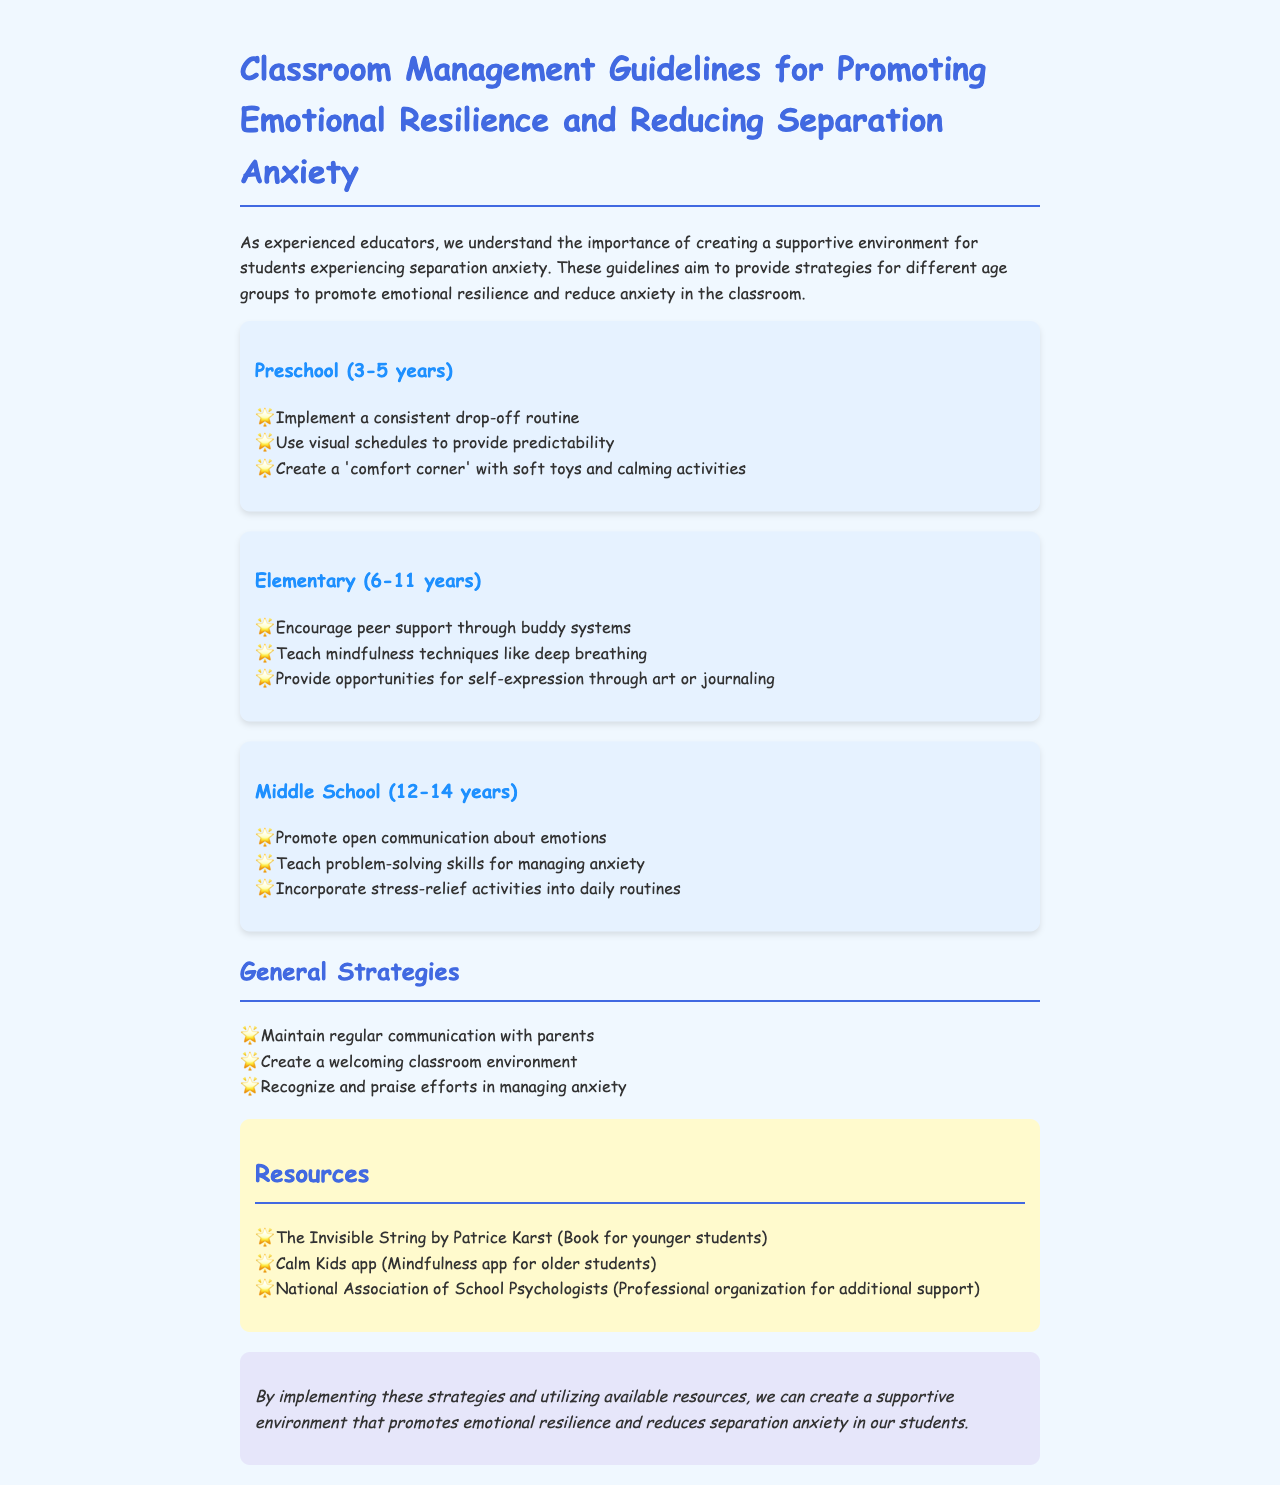What is the title of the document? The title is given at the top of the document and provides an overview of its content.
Answer: Classroom Management Guidelines for Promoting Emotional Resilience and Reducing Separation Anxiety How many age groups are discussed in the guidelines? The document outlines strategies for three distinct age groups to address separation anxiety.
Answer: Three What is one strategy for preschool students? The document lists specific strategies for each age group, including one for preschool students.
Answer: Implement a consistent drop-off routine Which mindfulness technique is taught to elementary students? The document mentions particular techniques and activities for elementary students to help with anxiety.
Answer: Deep breathing What type of communication is encouraged with parents? The document includes general strategies that involve ongoing interaction with parents.
Answer: Regular communication What mental health activities are suggested for middle schoolers? The guidelines indicate specific activities and skills designed to help middle school students manage anxiety.
Answer: Stress-relief activities What is one resource recommended for younger students? The document lists specific resources available to support students, particularly younger ones.
Answer: The Invisible String by Patrice Karst What is emphasized in the conclusion of the document? The conclusion sums up the main purpose of the strategies and resources discussed throughout the document.
Answer: Supportive environment 